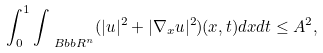<formula> <loc_0><loc_0><loc_500><loc_500>\int _ { 0 } ^ { 1 } \int _ { \ B b b R ^ { n } } ( | u | ^ { 2 } + | \nabla _ { x } u | ^ { 2 } ) ( x , t ) d x d t \leq A ^ { 2 } ,</formula> 